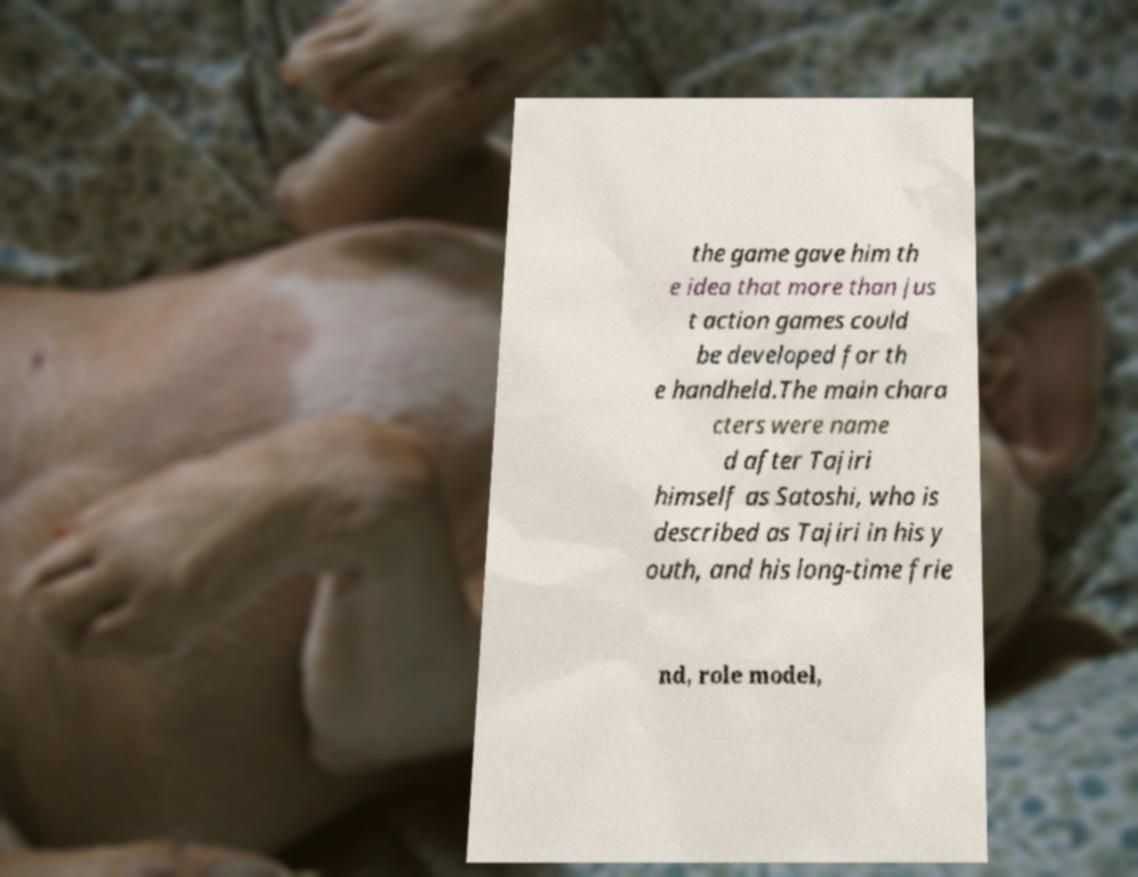For documentation purposes, I need the text within this image transcribed. Could you provide that? the game gave him th e idea that more than jus t action games could be developed for th e handheld.The main chara cters were name d after Tajiri himself as Satoshi, who is described as Tajiri in his y outh, and his long-time frie nd, role model, 